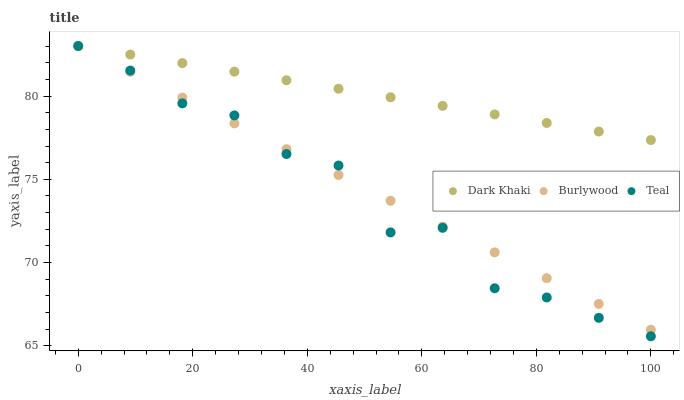Does Teal have the minimum area under the curve?
Answer yes or no. Yes. Does Dark Khaki have the maximum area under the curve?
Answer yes or no. Yes. Does Burlywood have the minimum area under the curve?
Answer yes or no. No. Does Burlywood have the maximum area under the curve?
Answer yes or no. No. Is Dark Khaki the smoothest?
Answer yes or no. Yes. Is Teal the roughest?
Answer yes or no. Yes. Is Burlywood the smoothest?
Answer yes or no. No. Is Burlywood the roughest?
Answer yes or no. No. Does Teal have the lowest value?
Answer yes or no. Yes. Does Burlywood have the lowest value?
Answer yes or no. No. Does Teal have the highest value?
Answer yes or no. Yes. Does Dark Khaki intersect Burlywood?
Answer yes or no. Yes. Is Dark Khaki less than Burlywood?
Answer yes or no. No. Is Dark Khaki greater than Burlywood?
Answer yes or no. No. 